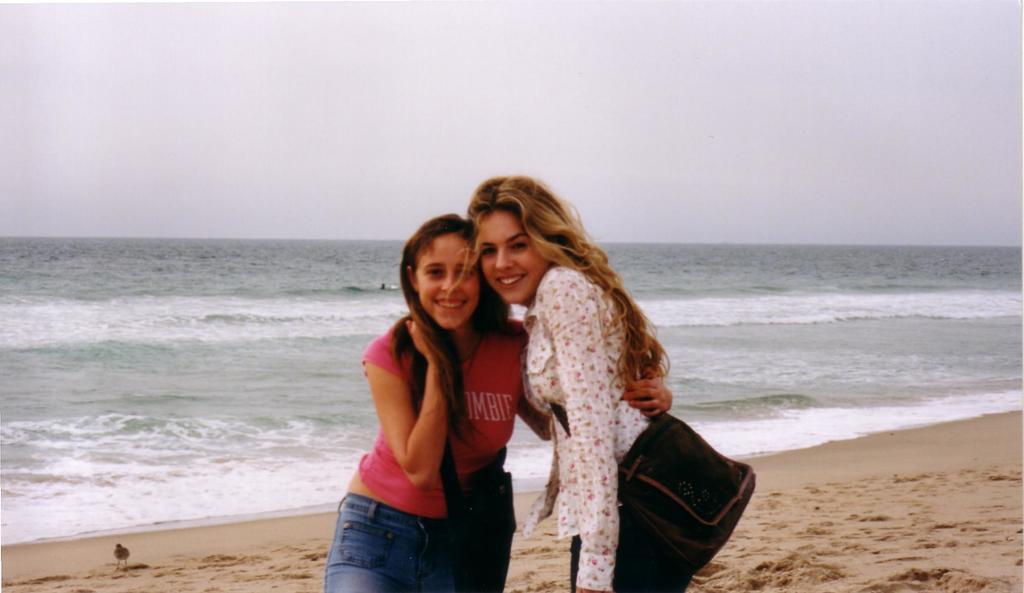Can you describe this image briefly? This image consists of two women standing near the beach. On the right, the woman is wearing a white shirt is also wearing a bag. On the left, the woman is wearing a pink T-shirt. At the bottom, there is sand. In the background, there is an ocean. At the top, there is a sky. 